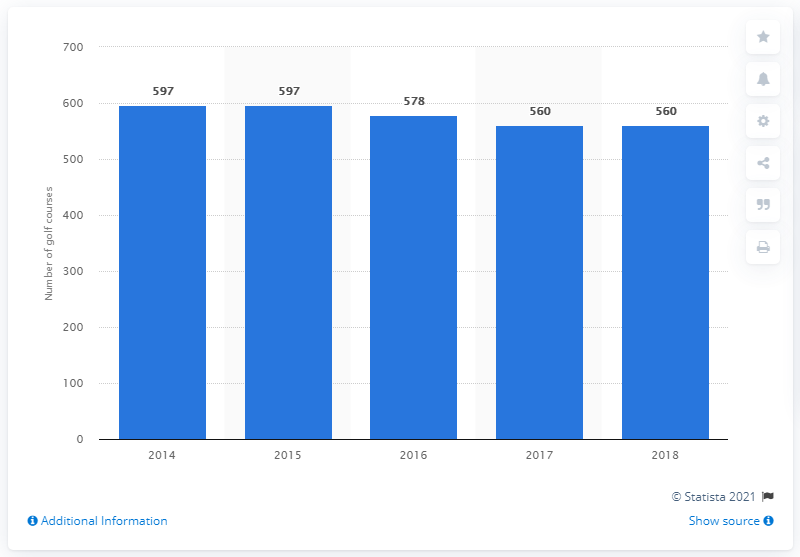How many golf courses were there in Scotland in 2018?
 560 